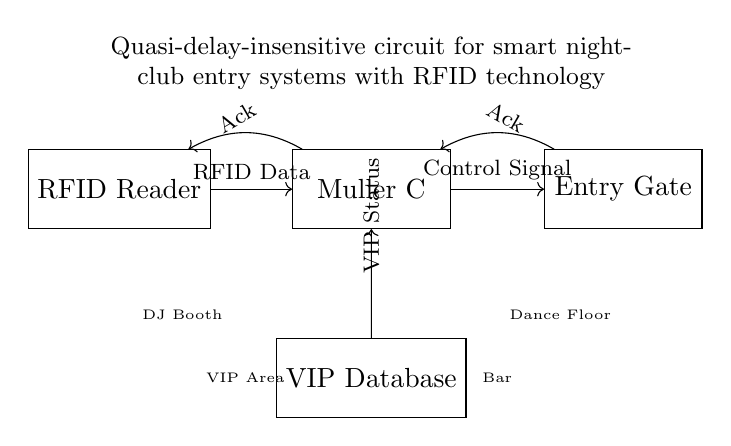What component is responsible for reading the RFID data? The RFID Reader is the component depicted at the left end of the diagram and is designated specifically for reading the RFID data from the tags.
Answer: RFID Reader What signal does the Muller C element output to the Entry Gate? The output from the Muller C element to the Entry Gate is labeled as the Control Signal, indicating that this is the command or signal directing the gate's operation.
Answer: Control Signal How does the VIP Database interact with the Muller C element? The VIP Database provides the VIP Status signal to the Muller C element, indicating whether a scanned RFID tag belongs to a VIP member or not. The connection is indicated by the arrow pointing from the database to the Muller C.
Answer: VIP Status How many acknowledgment signals are shown in the circuit? There are two acknowledgment signals (Ack), one directed from the RFID Reader to the Muller C and the other from the Muller C to the Entry Gate. Both are shown with arrows pointing back towards the respective components.
Answer: Two What does the presence of the DJ Booth and Dance Floor indicate in the circuit context? The DJ Booth and Dance Floor indicate additional party atmosphere elements surrounding the entry system, suggesting that the circuit is not only for entry control but also relates to the nightlife experience by specifying environment features.
Answer: Party atmosphere elements What type of circuit is this diagram illustrating? This circuit is a quasi-delay-insensitive circuit which means it can operate without having to wait for signals to settle, allowing for quicker responses in the context of a nightclub entry system.
Answer: Quasi-delay-insensitive 